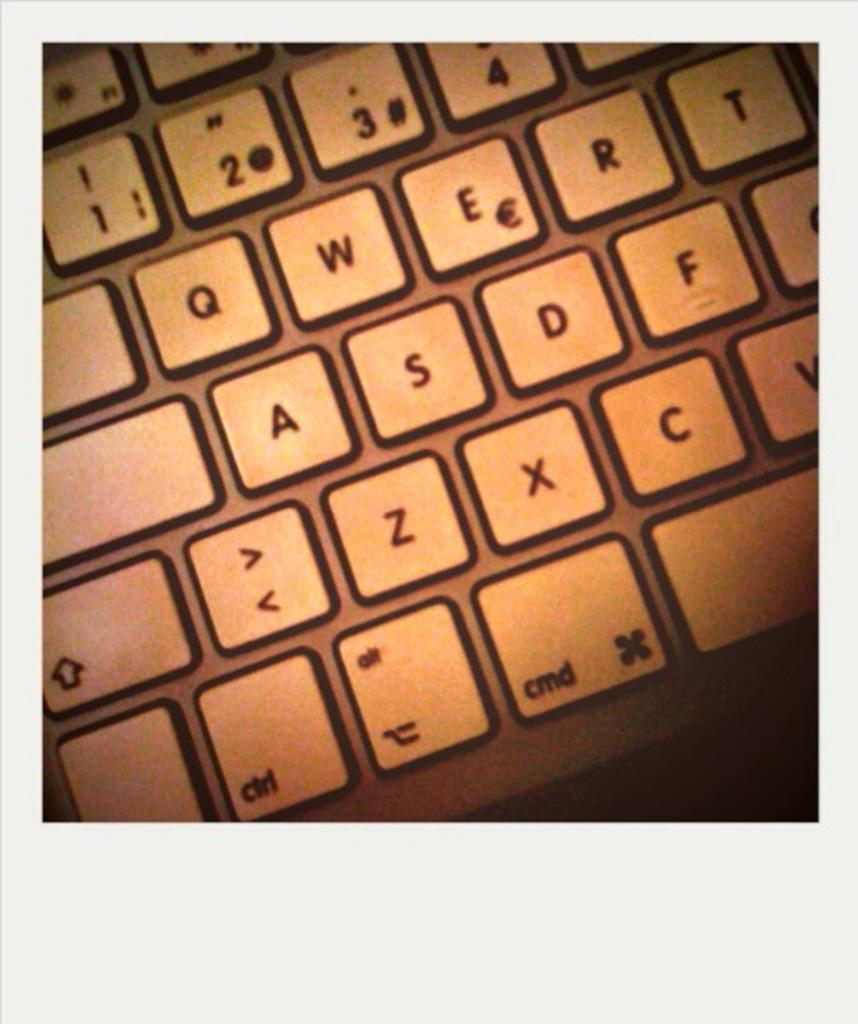<image>
Summarize the visual content of the image. A keyboard that has the numbers 1,2,3, and 4 at the top of it. 